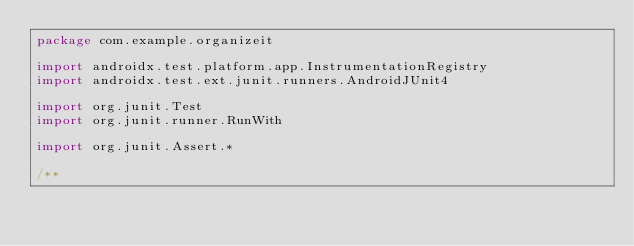<code> <loc_0><loc_0><loc_500><loc_500><_Kotlin_>package com.example.organizeit

import androidx.test.platform.app.InstrumentationRegistry
import androidx.test.ext.junit.runners.AndroidJUnit4

import org.junit.Test
import org.junit.runner.RunWith

import org.junit.Assert.*

/**</code> 